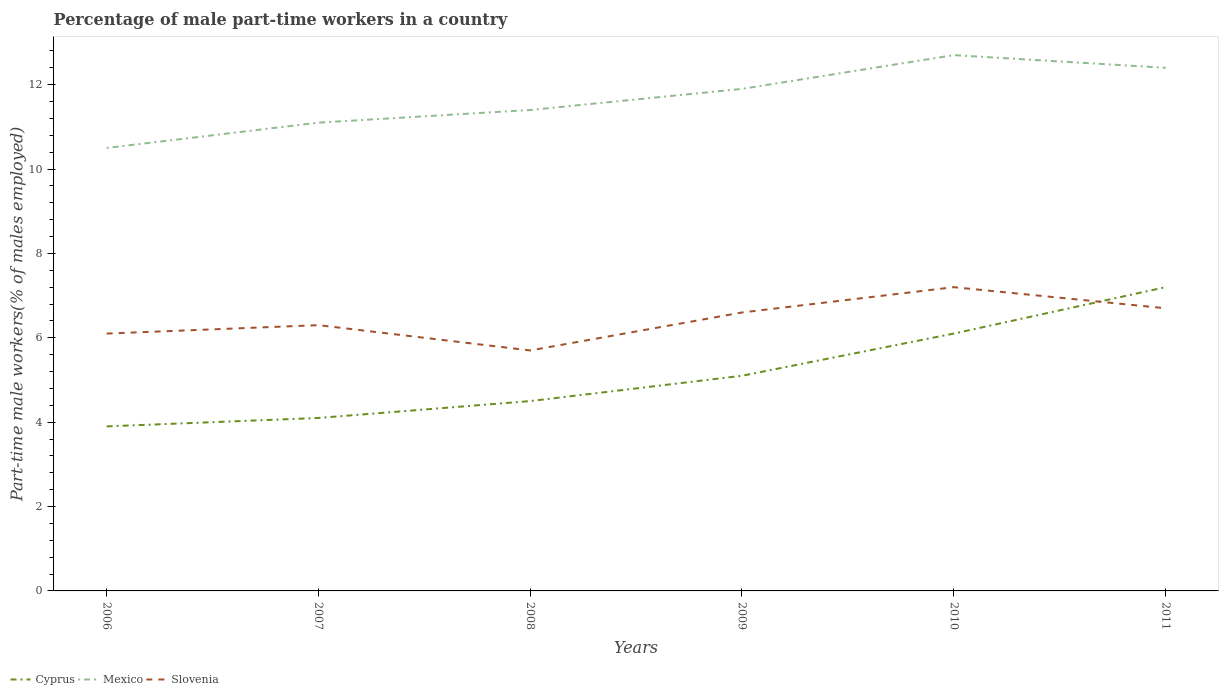Does the line corresponding to Slovenia intersect with the line corresponding to Cyprus?
Offer a terse response. Yes. Across all years, what is the maximum percentage of male part-time workers in Mexico?
Make the answer very short. 10.5. What is the total percentage of male part-time workers in Cyprus in the graph?
Your response must be concise. -2.1. What is the difference between the highest and the second highest percentage of male part-time workers in Mexico?
Offer a very short reply. 2.2. What is the difference between the highest and the lowest percentage of male part-time workers in Cyprus?
Your answer should be very brief. 2. How many lines are there?
Your answer should be very brief. 3. What is the difference between two consecutive major ticks on the Y-axis?
Keep it short and to the point. 2. Are the values on the major ticks of Y-axis written in scientific E-notation?
Provide a succinct answer. No. Does the graph contain grids?
Make the answer very short. No. How are the legend labels stacked?
Provide a short and direct response. Horizontal. What is the title of the graph?
Offer a terse response. Percentage of male part-time workers in a country. Does "Tonga" appear as one of the legend labels in the graph?
Your response must be concise. No. What is the label or title of the Y-axis?
Your answer should be very brief. Part-time male workers(% of males employed). What is the Part-time male workers(% of males employed) in Cyprus in 2006?
Give a very brief answer. 3.9. What is the Part-time male workers(% of males employed) in Slovenia in 2006?
Your answer should be compact. 6.1. What is the Part-time male workers(% of males employed) of Cyprus in 2007?
Offer a terse response. 4.1. What is the Part-time male workers(% of males employed) in Mexico in 2007?
Your response must be concise. 11.1. What is the Part-time male workers(% of males employed) of Slovenia in 2007?
Keep it short and to the point. 6.3. What is the Part-time male workers(% of males employed) of Mexico in 2008?
Your response must be concise. 11.4. What is the Part-time male workers(% of males employed) of Slovenia in 2008?
Ensure brevity in your answer.  5.7. What is the Part-time male workers(% of males employed) of Cyprus in 2009?
Your response must be concise. 5.1. What is the Part-time male workers(% of males employed) in Mexico in 2009?
Offer a very short reply. 11.9. What is the Part-time male workers(% of males employed) of Slovenia in 2009?
Your answer should be very brief. 6.6. What is the Part-time male workers(% of males employed) in Cyprus in 2010?
Your answer should be compact. 6.1. What is the Part-time male workers(% of males employed) in Mexico in 2010?
Your answer should be compact. 12.7. What is the Part-time male workers(% of males employed) in Slovenia in 2010?
Make the answer very short. 7.2. What is the Part-time male workers(% of males employed) in Cyprus in 2011?
Your response must be concise. 7.2. What is the Part-time male workers(% of males employed) in Mexico in 2011?
Your response must be concise. 12.4. What is the Part-time male workers(% of males employed) in Slovenia in 2011?
Make the answer very short. 6.7. Across all years, what is the maximum Part-time male workers(% of males employed) of Cyprus?
Give a very brief answer. 7.2. Across all years, what is the maximum Part-time male workers(% of males employed) in Mexico?
Your answer should be compact. 12.7. Across all years, what is the maximum Part-time male workers(% of males employed) of Slovenia?
Offer a terse response. 7.2. Across all years, what is the minimum Part-time male workers(% of males employed) of Cyprus?
Ensure brevity in your answer.  3.9. Across all years, what is the minimum Part-time male workers(% of males employed) in Slovenia?
Provide a succinct answer. 5.7. What is the total Part-time male workers(% of males employed) of Cyprus in the graph?
Offer a terse response. 30.9. What is the total Part-time male workers(% of males employed) of Slovenia in the graph?
Keep it short and to the point. 38.6. What is the difference between the Part-time male workers(% of males employed) of Slovenia in 2006 and that in 2007?
Your answer should be very brief. -0.2. What is the difference between the Part-time male workers(% of males employed) in Cyprus in 2006 and that in 2008?
Keep it short and to the point. -0.6. What is the difference between the Part-time male workers(% of males employed) in Cyprus in 2006 and that in 2009?
Your answer should be compact. -1.2. What is the difference between the Part-time male workers(% of males employed) in Mexico in 2006 and that in 2009?
Your answer should be compact. -1.4. What is the difference between the Part-time male workers(% of males employed) in Cyprus in 2006 and that in 2010?
Provide a succinct answer. -2.2. What is the difference between the Part-time male workers(% of males employed) of Mexico in 2006 and that in 2010?
Your answer should be compact. -2.2. What is the difference between the Part-time male workers(% of males employed) of Cyprus in 2007 and that in 2008?
Give a very brief answer. -0.4. What is the difference between the Part-time male workers(% of males employed) of Slovenia in 2007 and that in 2008?
Offer a very short reply. 0.6. What is the difference between the Part-time male workers(% of males employed) in Cyprus in 2007 and that in 2009?
Make the answer very short. -1. What is the difference between the Part-time male workers(% of males employed) in Slovenia in 2007 and that in 2009?
Provide a short and direct response. -0.3. What is the difference between the Part-time male workers(% of males employed) in Cyprus in 2007 and that in 2010?
Offer a very short reply. -2. What is the difference between the Part-time male workers(% of males employed) of Mexico in 2007 and that in 2010?
Your answer should be very brief. -1.6. What is the difference between the Part-time male workers(% of males employed) in Slovenia in 2007 and that in 2010?
Offer a terse response. -0.9. What is the difference between the Part-time male workers(% of males employed) of Slovenia in 2007 and that in 2011?
Offer a terse response. -0.4. What is the difference between the Part-time male workers(% of males employed) of Cyprus in 2008 and that in 2009?
Offer a terse response. -0.6. What is the difference between the Part-time male workers(% of males employed) of Mexico in 2008 and that in 2009?
Offer a terse response. -0.5. What is the difference between the Part-time male workers(% of males employed) in Cyprus in 2008 and that in 2010?
Keep it short and to the point. -1.6. What is the difference between the Part-time male workers(% of males employed) of Mexico in 2008 and that in 2010?
Keep it short and to the point. -1.3. What is the difference between the Part-time male workers(% of males employed) of Slovenia in 2008 and that in 2010?
Offer a very short reply. -1.5. What is the difference between the Part-time male workers(% of males employed) of Slovenia in 2008 and that in 2011?
Ensure brevity in your answer.  -1. What is the difference between the Part-time male workers(% of males employed) of Cyprus in 2009 and that in 2010?
Offer a terse response. -1. What is the difference between the Part-time male workers(% of males employed) in Cyprus in 2009 and that in 2011?
Offer a terse response. -2.1. What is the difference between the Part-time male workers(% of males employed) of Cyprus in 2010 and that in 2011?
Offer a terse response. -1.1. What is the difference between the Part-time male workers(% of males employed) of Mexico in 2010 and that in 2011?
Offer a terse response. 0.3. What is the difference between the Part-time male workers(% of males employed) of Slovenia in 2010 and that in 2011?
Offer a terse response. 0.5. What is the difference between the Part-time male workers(% of males employed) of Cyprus in 2006 and the Part-time male workers(% of males employed) of Mexico in 2007?
Ensure brevity in your answer.  -7.2. What is the difference between the Part-time male workers(% of males employed) of Cyprus in 2006 and the Part-time male workers(% of males employed) of Slovenia in 2007?
Your answer should be compact. -2.4. What is the difference between the Part-time male workers(% of males employed) in Cyprus in 2006 and the Part-time male workers(% of males employed) in Mexico in 2008?
Offer a terse response. -7.5. What is the difference between the Part-time male workers(% of males employed) of Cyprus in 2006 and the Part-time male workers(% of males employed) of Slovenia in 2008?
Your answer should be very brief. -1.8. What is the difference between the Part-time male workers(% of males employed) in Mexico in 2006 and the Part-time male workers(% of males employed) in Slovenia in 2008?
Make the answer very short. 4.8. What is the difference between the Part-time male workers(% of males employed) of Mexico in 2006 and the Part-time male workers(% of males employed) of Slovenia in 2011?
Make the answer very short. 3.8. What is the difference between the Part-time male workers(% of males employed) in Cyprus in 2007 and the Part-time male workers(% of males employed) in Slovenia in 2008?
Your response must be concise. -1.6. What is the difference between the Part-time male workers(% of males employed) in Mexico in 2007 and the Part-time male workers(% of males employed) in Slovenia in 2008?
Provide a short and direct response. 5.4. What is the difference between the Part-time male workers(% of males employed) of Cyprus in 2007 and the Part-time male workers(% of males employed) of Mexico in 2009?
Offer a very short reply. -7.8. What is the difference between the Part-time male workers(% of males employed) in Mexico in 2007 and the Part-time male workers(% of males employed) in Slovenia in 2009?
Provide a short and direct response. 4.5. What is the difference between the Part-time male workers(% of males employed) of Cyprus in 2007 and the Part-time male workers(% of males employed) of Mexico in 2010?
Ensure brevity in your answer.  -8.6. What is the difference between the Part-time male workers(% of males employed) of Mexico in 2007 and the Part-time male workers(% of males employed) of Slovenia in 2011?
Keep it short and to the point. 4.4. What is the difference between the Part-time male workers(% of males employed) in Cyprus in 2008 and the Part-time male workers(% of males employed) in Mexico in 2009?
Make the answer very short. -7.4. What is the difference between the Part-time male workers(% of males employed) in Cyprus in 2008 and the Part-time male workers(% of males employed) in Slovenia in 2009?
Your answer should be compact. -2.1. What is the difference between the Part-time male workers(% of males employed) in Mexico in 2008 and the Part-time male workers(% of males employed) in Slovenia in 2009?
Provide a succinct answer. 4.8. What is the difference between the Part-time male workers(% of males employed) of Cyprus in 2008 and the Part-time male workers(% of males employed) of Slovenia in 2011?
Provide a succinct answer. -2.2. What is the difference between the Part-time male workers(% of males employed) of Cyprus in 2009 and the Part-time male workers(% of males employed) of Mexico in 2010?
Make the answer very short. -7.6. What is the difference between the Part-time male workers(% of males employed) in Cyprus in 2009 and the Part-time male workers(% of males employed) in Slovenia in 2010?
Your answer should be compact. -2.1. What is the difference between the Part-time male workers(% of males employed) of Mexico in 2009 and the Part-time male workers(% of males employed) of Slovenia in 2010?
Give a very brief answer. 4.7. What is the difference between the Part-time male workers(% of males employed) of Cyprus in 2009 and the Part-time male workers(% of males employed) of Mexico in 2011?
Offer a terse response. -7.3. What is the difference between the Part-time male workers(% of males employed) of Mexico in 2009 and the Part-time male workers(% of males employed) of Slovenia in 2011?
Your answer should be compact. 5.2. What is the difference between the Part-time male workers(% of males employed) of Cyprus in 2010 and the Part-time male workers(% of males employed) of Slovenia in 2011?
Your answer should be very brief. -0.6. What is the average Part-time male workers(% of males employed) in Cyprus per year?
Ensure brevity in your answer.  5.15. What is the average Part-time male workers(% of males employed) in Mexico per year?
Provide a succinct answer. 11.67. What is the average Part-time male workers(% of males employed) in Slovenia per year?
Make the answer very short. 6.43. In the year 2006, what is the difference between the Part-time male workers(% of males employed) of Cyprus and Part-time male workers(% of males employed) of Mexico?
Provide a succinct answer. -6.6. In the year 2007, what is the difference between the Part-time male workers(% of males employed) of Cyprus and Part-time male workers(% of males employed) of Slovenia?
Offer a very short reply. -2.2. In the year 2008, what is the difference between the Part-time male workers(% of males employed) in Cyprus and Part-time male workers(% of males employed) in Mexico?
Keep it short and to the point. -6.9. In the year 2008, what is the difference between the Part-time male workers(% of males employed) of Mexico and Part-time male workers(% of males employed) of Slovenia?
Ensure brevity in your answer.  5.7. In the year 2010, what is the difference between the Part-time male workers(% of males employed) in Cyprus and Part-time male workers(% of males employed) in Mexico?
Offer a very short reply. -6.6. In the year 2010, what is the difference between the Part-time male workers(% of males employed) in Cyprus and Part-time male workers(% of males employed) in Slovenia?
Keep it short and to the point. -1.1. In the year 2010, what is the difference between the Part-time male workers(% of males employed) of Mexico and Part-time male workers(% of males employed) of Slovenia?
Offer a very short reply. 5.5. In the year 2011, what is the difference between the Part-time male workers(% of males employed) in Cyprus and Part-time male workers(% of males employed) in Slovenia?
Your answer should be compact. 0.5. In the year 2011, what is the difference between the Part-time male workers(% of males employed) in Mexico and Part-time male workers(% of males employed) in Slovenia?
Make the answer very short. 5.7. What is the ratio of the Part-time male workers(% of males employed) of Cyprus in 2006 to that in 2007?
Your answer should be compact. 0.95. What is the ratio of the Part-time male workers(% of males employed) of Mexico in 2006 to that in 2007?
Your answer should be compact. 0.95. What is the ratio of the Part-time male workers(% of males employed) in Slovenia in 2006 to that in 2007?
Your answer should be compact. 0.97. What is the ratio of the Part-time male workers(% of males employed) in Cyprus in 2006 to that in 2008?
Offer a terse response. 0.87. What is the ratio of the Part-time male workers(% of males employed) in Mexico in 2006 to that in 2008?
Make the answer very short. 0.92. What is the ratio of the Part-time male workers(% of males employed) in Slovenia in 2006 to that in 2008?
Provide a short and direct response. 1.07. What is the ratio of the Part-time male workers(% of males employed) in Cyprus in 2006 to that in 2009?
Provide a succinct answer. 0.76. What is the ratio of the Part-time male workers(% of males employed) of Mexico in 2006 to that in 2009?
Make the answer very short. 0.88. What is the ratio of the Part-time male workers(% of males employed) of Slovenia in 2006 to that in 2009?
Ensure brevity in your answer.  0.92. What is the ratio of the Part-time male workers(% of males employed) of Cyprus in 2006 to that in 2010?
Make the answer very short. 0.64. What is the ratio of the Part-time male workers(% of males employed) of Mexico in 2006 to that in 2010?
Provide a short and direct response. 0.83. What is the ratio of the Part-time male workers(% of males employed) in Slovenia in 2006 to that in 2010?
Keep it short and to the point. 0.85. What is the ratio of the Part-time male workers(% of males employed) of Cyprus in 2006 to that in 2011?
Keep it short and to the point. 0.54. What is the ratio of the Part-time male workers(% of males employed) in Mexico in 2006 to that in 2011?
Ensure brevity in your answer.  0.85. What is the ratio of the Part-time male workers(% of males employed) of Slovenia in 2006 to that in 2011?
Your answer should be compact. 0.91. What is the ratio of the Part-time male workers(% of males employed) of Cyprus in 2007 to that in 2008?
Your response must be concise. 0.91. What is the ratio of the Part-time male workers(% of males employed) of Mexico in 2007 to that in 2008?
Keep it short and to the point. 0.97. What is the ratio of the Part-time male workers(% of males employed) of Slovenia in 2007 to that in 2008?
Provide a succinct answer. 1.11. What is the ratio of the Part-time male workers(% of males employed) in Cyprus in 2007 to that in 2009?
Your answer should be compact. 0.8. What is the ratio of the Part-time male workers(% of males employed) of Mexico in 2007 to that in 2009?
Provide a short and direct response. 0.93. What is the ratio of the Part-time male workers(% of males employed) in Slovenia in 2007 to that in 2009?
Your answer should be very brief. 0.95. What is the ratio of the Part-time male workers(% of males employed) in Cyprus in 2007 to that in 2010?
Give a very brief answer. 0.67. What is the ratio of the Part-time male workers(% of males employed) in Mexico in 2007 to that in 2010?
Your answer should be compact. 0.87. What is the ratio of the Part-time male workers(% of males employed) in Cyprus in 2007 to that in 2011?
Keep it short and to the point. 0.57. What is the ratio of the Part-time male workers(% of males employed) of Mexico in 2007 to that in 2011?
Your response must be concise. 0.9. What is the ratio of the Part-time male workers(% of males employed) in Slovenia in 2007 to that in 2011?
Offer a very short reply. 0.94. What is the ratio of the Part-time male workers(% of males employed) of Cyprus in 2008 to that in 2009?
Your answer should be very brief. 0.88. What is the ratio of the Part-time male workers(% of males employed) of Mexico in 2008 to that in 2009?
Your answer should be compact. 0.96. What is the ratio of the Part-time male workers(% of males employed) of Slovenia in 2008 to that in 2009?
Keep it short and to the point. 0.86. What is the ratio of the Part-time male workers(% of males employed) in Cyprus in 2008 to that in 2010?
Keep it short and to the point. 0.74. What is the ratio of the Part-time male workers(% of males employed) in Mexico in 2008 to that in 2010?
Ensure brevity in your answer.  0.9. What is the ratio of the Part-time male workers(% of males employed) in Slovenia in 2008 to that in 2010?
Provide a short and direct response. 0.79. What is the ratio of the Part-time male workers(% of males employed) of Cyprus in 2008 to that in 2011?
Your answer should be compact. 0.62. What is the ratio of the Part-time male workers(% of males employed) in Mexico in 2008 to that in 2011?
Your answer should be very brief. 0.92. What is the ratio of the Part-time male workers(% of males employed) of Slovenia in 2008 to that in 2011?
Keep it short and to the point. 0.85. What is the ratio of the Part-time male workers(% of males employed) in Cyprus in 2009 to that in 2010?
Ensure brevity in your answer.  0.84. What is the ratio of the Part-time male workers(% of males employed) of Mexico in 2009 to that in 2010?
Provide a succinct answer. 0.94. What is the ratio of the Part-time male workers(% of males employed) in Cyprus in 2009 to that in 2011?
Keep it short and to the point. 0.71. What is the ratio of the Part-time male workers(% of males employed) of Mexico in 2009 to that in 2011?
Keep it short and to the point. 0.96. What is the ratio of the Part-time male workers(% of males employed) of Slovenia in 2009 to that in 2011?
Ensure brevity in your answer.  0.99. What is the ratio of the Part-time male workers(% of males employed) in Cyprus in 2010 to that in 2011?
Your response must be concise. 0.85. What is the ratio of the Part-time male workers(% of males employed) in Mexico in 2010 to that in 2011?
Ensure brevity in your answer.  1.02. What is the ratio of the Part-time male workers(% of males employed) in Slovenia in 2010 to that in 2011?
Offer a terse response. 1.07. What is the difference between the highest and the second highest Part-time male workers(% of males employed) of Cyprus?
Your answer should be very brief. 1.1. What is the difference between the highest and the lowest Part-time male workers(% of males employed) in Cyprus?
Your response must be concise. 3.3. What is the difference between the highest and the lowest Part-time male workers(% of males employed) in Mexico?
Provide a succinct answer. 2.2. 